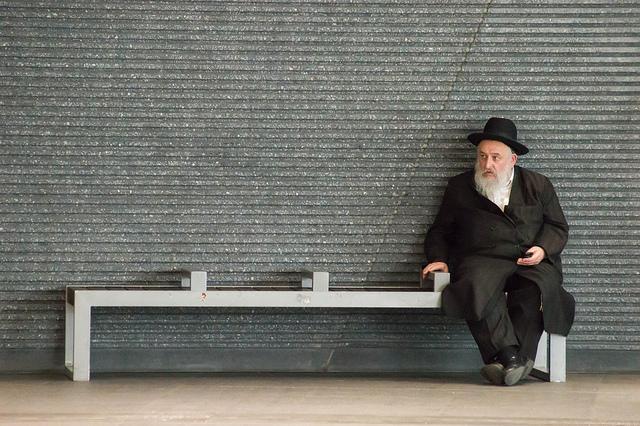How many benches are there?
Give a very brief answer. 1. How many people can you see?
Give a very brief answer. 1. 